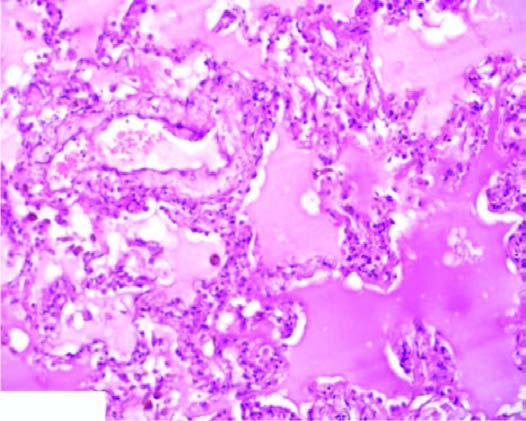what are congested?
Answer the question using a single word or phrase. The alveolar capillaries 